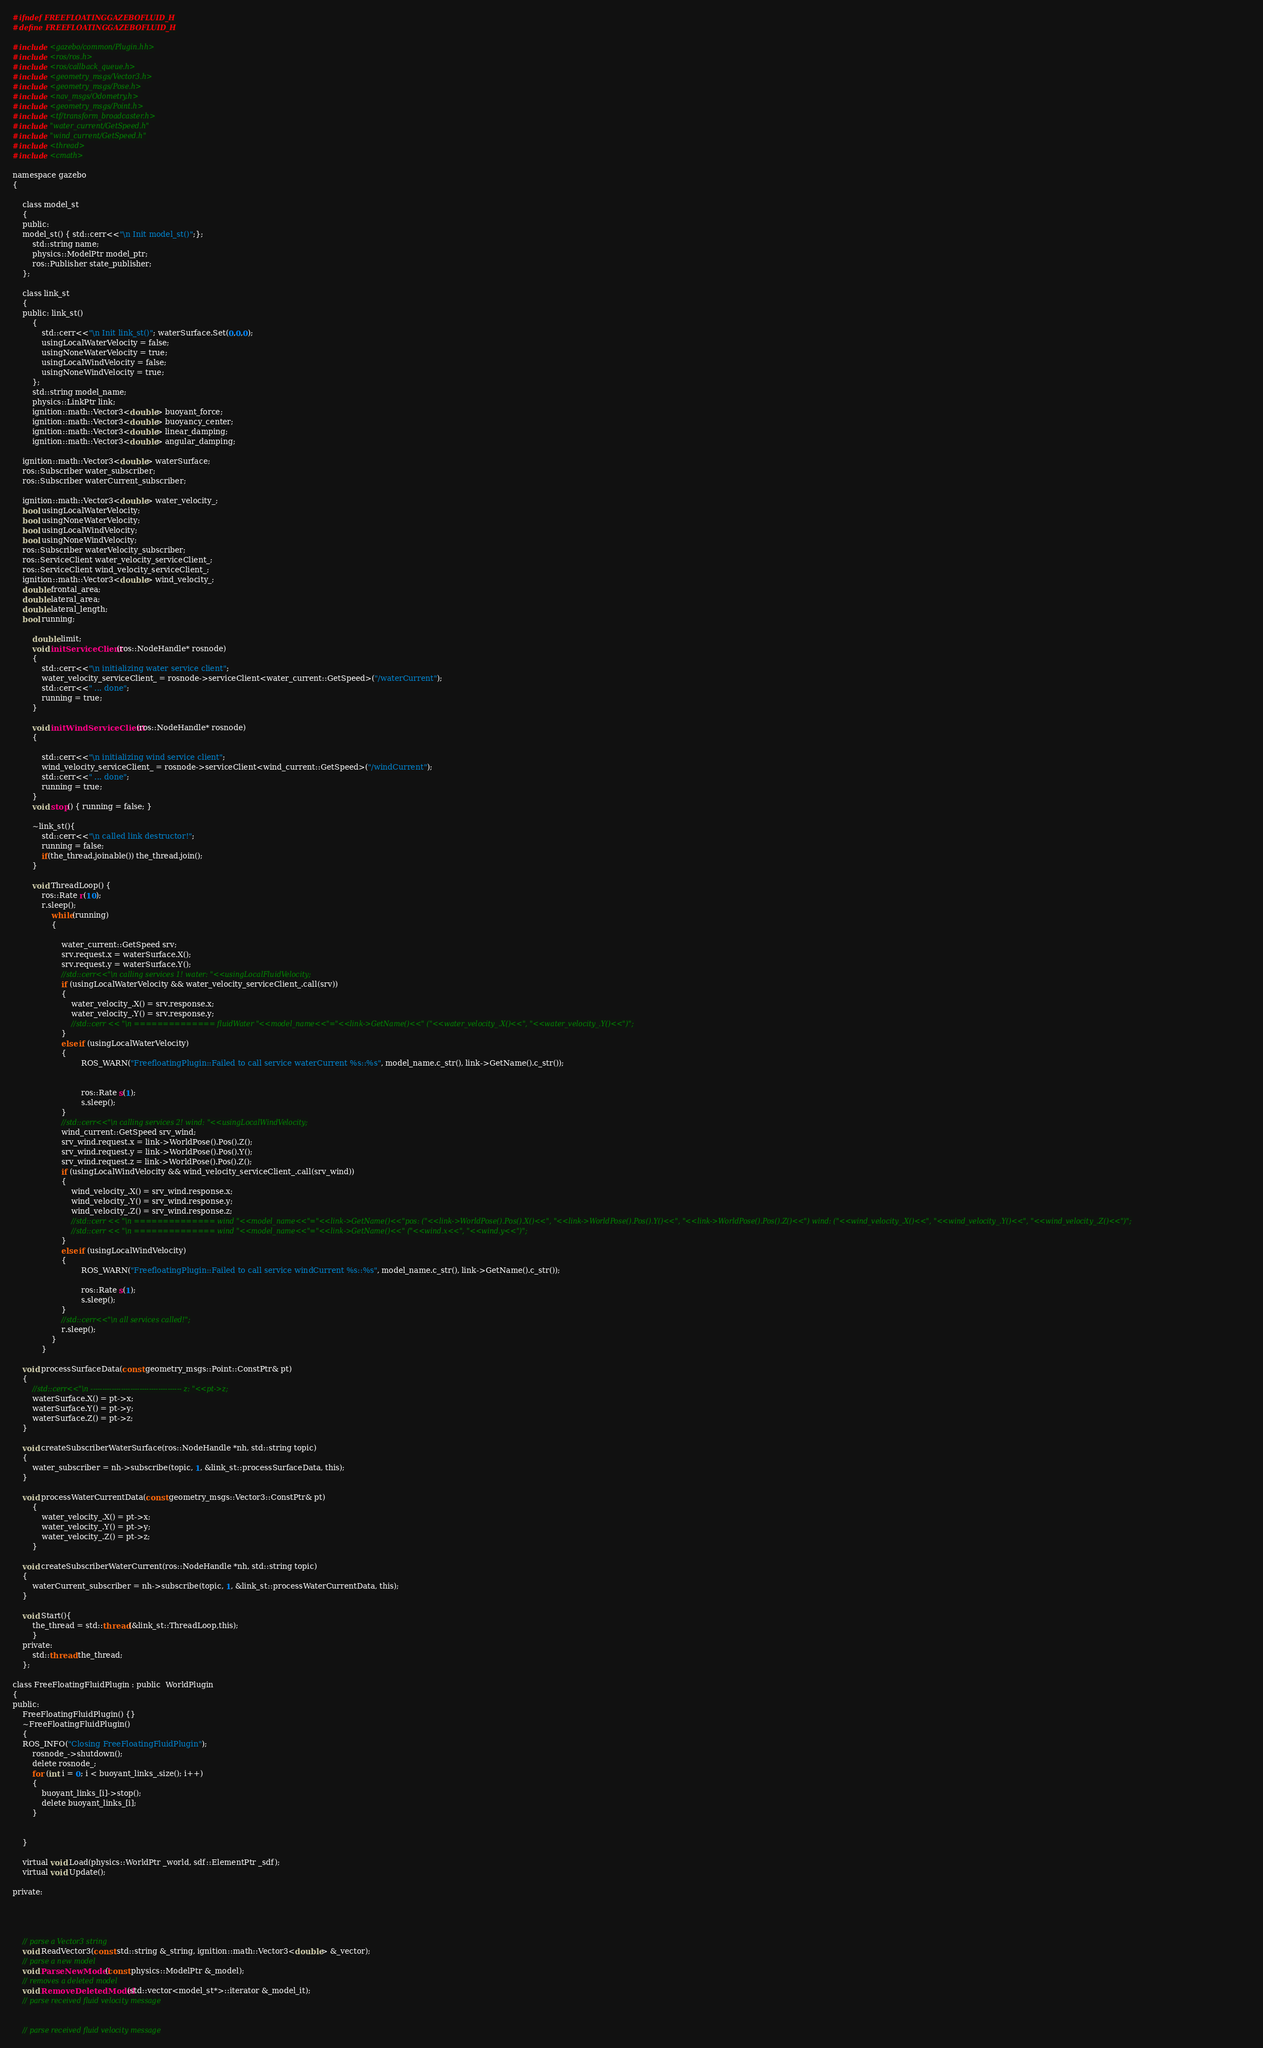Convert code to text. <code><loc_0><loc_0><loc_500><loc_500><_C_>#ifndef FREEFLOATINGGAZEBOFLUID_H
#define FREEFLOATINGGAZEBOFLUID_H

#include <gazebo/common/Plugin.hh>
#include <ros/ros.h>
#include <ros/callback_queue.h>
#include <geometry_msgs/Vector3.h>
#include <geometry_msgs/Pose.h>
#include <nav_msgs/Odometry.h>
#include <geometry_msgs/Point.h>
#include <tf/transform_broadcaster.h>
#include "water_current/GetSpeed.h"
#include "wind_current/GetSpeed.h"
#include <thread>
#include <cmath>

namespace gazebo
{

    class model_st
    {
	public:
	model_st() { std::cerr<<"\n Init model_st()";};
        std::string name;
        physics::ModelPtr model_ptr;
        ros::Publisher state_publisher;
    };

    class link_st
    {
	public: link_st()
		{
			std::cerr<<"\n Init link_st()"; waterSurface.Set(0,0,0);
			usingLocalWaterVelocity = false;
			usingNoneWaterVelocity = true;
			usingLocalWindVelocity = false;
			usingNoneWindVelocity = true;
		};
        std::string model_name;
        physics::LinkPtr link;
        ignition::math::Vector3<double> buoyant_force;
        ignition::math::Vector3<double> buoyancy_center;
        ignition::math::Vector3<double> linear_damping;
        ignition::math::Vector3<double> angular_damping;

	ignition::math::Vector3<double> waterSurface;
	ros::Subscriber water_subscriber;
	ros::Subscriber waterCurrent_subscriber;

	ignition::math::Vector3<double> water_velocity_;
	bool usingLocalWaterVelocity;
	bool usingNoneWaterVelocity;
	bool usingLocalWindVelocity;
	bool usingNoneWindVelocity;
    ros::Subscriber waterVelocity_subscriber;
    ros::ServiceClient water_velocity_serviceClient_;
    ros::ServiceClient wind_velocity_serviceClient_;
	ignition::math::Vector3<double> wind_velocity_;
	double frontal_area;
	double lateral_area;
	double lateral_length;
    bool running;

        double limit;
        void initServiceClient(ros::NodeHandle* rosnode)
        {
        	std::cerr<<"\n initializing water service client";
        	water_velocity_serviceClient_ = rosnode->serviceClient<water_current::GetSpeed>("/waterCurrent");
        	std::cerr<<" ... done";
        	running = true;
        }

        void initWindServiceClient(ros::NodeHandle* rosnode)
		{

			std::cerr<<"\n initializing wind service client";
			wind_velocity_serviceClient_ = rosnode->serviceClient<wind_current::GetSpeed>("/windCurrent");
			std::cerr<<" ... done";
			running = true;
		}
        void stop() { running = false; }

        ~link_st(){
        	std::cerr<<"\n called link destructor!";
        	running = false;
			if(the_thread.joinable()) the_thread.join();
		}

        void ThreadLoop() {
        	ros::Rate r(10);
        	r.sleep();
				while(running)
				{

					water_current::GetSpeed srv;
					srv.request.x = waterSurface.X();
					srv.request.y = waterSurface.Y();
					//std::cerr<<"\n calling services 1! water: "<<usingLocalFluidVelocity;
					if (usingLocalWaterVelocity && water_velocity_serviceClient_.call(srv))
					{
						water_velocity_.X() = srv.response.x;
						water_velocity_.Y() = srv.response.y;
						//std::cerr << "\n ============== fluidWater "<<model_name<<"="<<link->GetName()<<" ("<<water_velocity_.X()<<", "<<water_velocity_.Y()<<")";
					}
					else if (usingLocalWaterVelocity)
					{
							ROS_WARN("FreefloatingPlugin::Failed to call service waterCurrent %s::%s", model_name.c_str(), link->GetName().c_str());


							ros::Rate s(1);
							s.sleep();
					}
					//std::cerr<<"\n calling services 2! wind: "<<usingLocalWindVelocity;
					wind_current::GetSpeed srv_wind;
					srv_wind.request.x = link->WorldPose().Pos().Z();
					srv_wind.request.y = link->WorldPose().Pos().Y();
					srv_wind.request.z = link->WorldPose().Pos().Z();
					if (usingLocalWindVelocity && wind_velocity_serviceClient_.call(srv_wind))
					{
						wind_velocity_.X() = srv_wind.response.x;
						wind_velocity_.Y() = srv_wind.response.y;
						wind_velocity_.Z() = srv_wind.response.z;
						//std::cerr << "\n ============== wind "<<model_name<<"="<<link->GetName()<<"pos: ("<<link->WorldPose().Pos().X()<<", "<<link->WorldPose().Pos().Y()<<", "<<link->WorldPose().Pos().Z()<<") wind: ("<<wind_velocity_.X()<<", "<<wind_velocity_.Y()<<", "<<wind_velocity_.Z()<<")";
						//std::cerr << "\n ============== wind "<<model_name<<"="<<link->GetName()<<" ("<<wind.x<<", "<<wind.y<<")";
					}
					else if (usingLocalWindVelocity)
					{
							ROS_WARN("FreefloatingPlugin::Failed to call service windCurrent %s::%s", model_name.c_str(), link->GetName().c_str());

							ros::Rate s(1);
							s.sleep();
					}
					//std::cerr<<"\n all services called!";
					r.sleep();
				}
            }

	void processSurfaceData(const geometry_msgs::Point::ConstPtr& pt)
	{
		//std::cerr<<"\n --------------------------------------- z: "<<pt->z;
		waterSurface.X() = pt->x;
		waterSurface.Y() = pt->y;
		waterSurface.Z() = pt->z;
	}

	void createSubscriberWaterSurface(ros::NodeHandle *nh, std::string topic)
	{
		water_subscriber = nh->subscribe(topic, 1, &link_st::processSurfaceData, this);
	}

	void processWaterCurrentData(const geometry_msgs::Vector3::ConstPtr& pt)
		{
			water_velocity_.X() = pt->x;
			water_velocity_.Y() = pt->y;
			water_velocity_.Z() = pt->z;
		}

	void createSubscriberWaterCurrent(ros::NodeHandle *nh, std::string topic)
	{
		waterCurrent_subscriber = nh->subscribe(topic, 1, &link_st::processWaterCurrentData, this);
	}

	void Start(){
		the_thread = std::thread(&link_st::ThreadLoop,this);
	    }
	private:
	    std::thread the_thread;
    };

class FreeFloatingFluidPlugin : public  WorldPlugin
{
public:
    FreeFloatingFluidPlugin() {}
    ~FreeFloatingFluidPlugin()
    {
	ROS_INFO("Closing FreeFloatingFluidPlugin");
        rosnode_->shutdown();
        delete rosnode_;
        for (int i = 0; i < buoyant_links_.size(); i++)
		{
			buoyant_links_[i]->stop();
			delete buoyant_links_[i];
		}


    }

    virtual void Load(physics::WorldPtr _world, sdf::ElementPtr _sdf);
    virtual void Update();

private:




    // parse a Vector3 string
    void ReadVector3(const std::string &_string, ignition::math::Vector3<double> &_vector);
    // parse a new model
    void ParseNewModel(const physics::ModelPtr &_model);
    // removes a deleted model
    void RemoveDeletedModel(std::vector<model_st*>::iterator &_model_it);
    // parse received fluid velocity message


    // parse received fluid velocity message</code> 